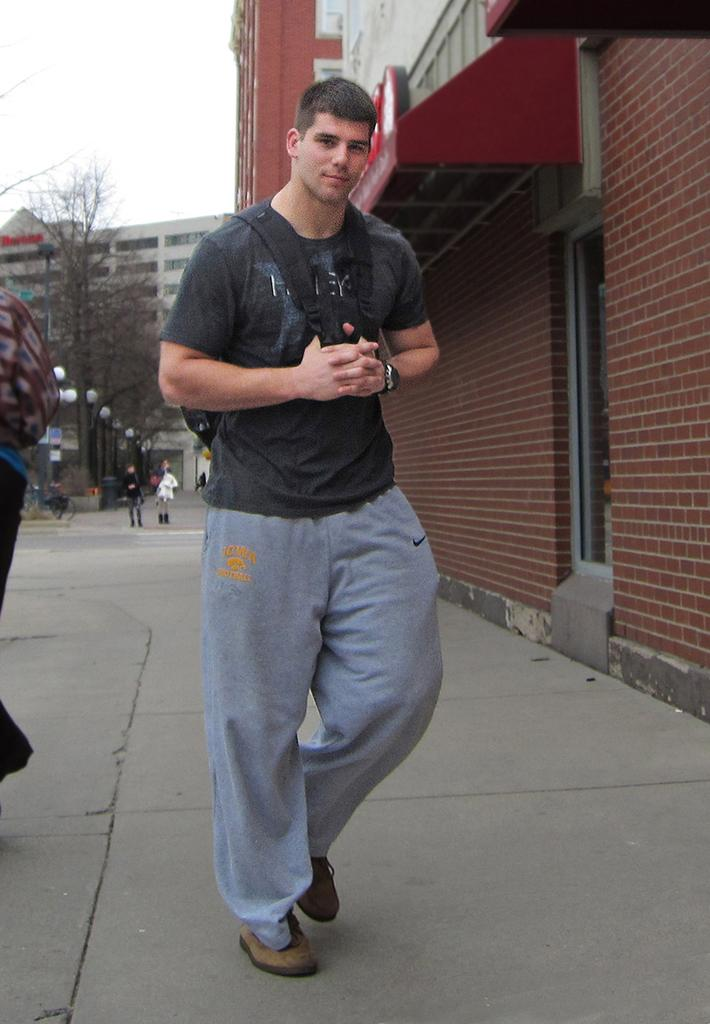Where was the image taken? The image was clicked outside. What is the main subject of the image? There is a person in the middle of the image. What is the person wearing on their upper body? The person is wearing a black T-shirt. What accessory is the person carrying on their back? The person is wearing a backpack. What type of vegetation can be seen on the left side of the image? There is a tree on the left side of the image. What type of structures are visible in the middle of the image? There are buildings in the middle of the image. What type of skin is visible on the person's face in the image? There is no information about the person's skin in the image. Where can you find the market in the image? There is no mention of a market in the image. 